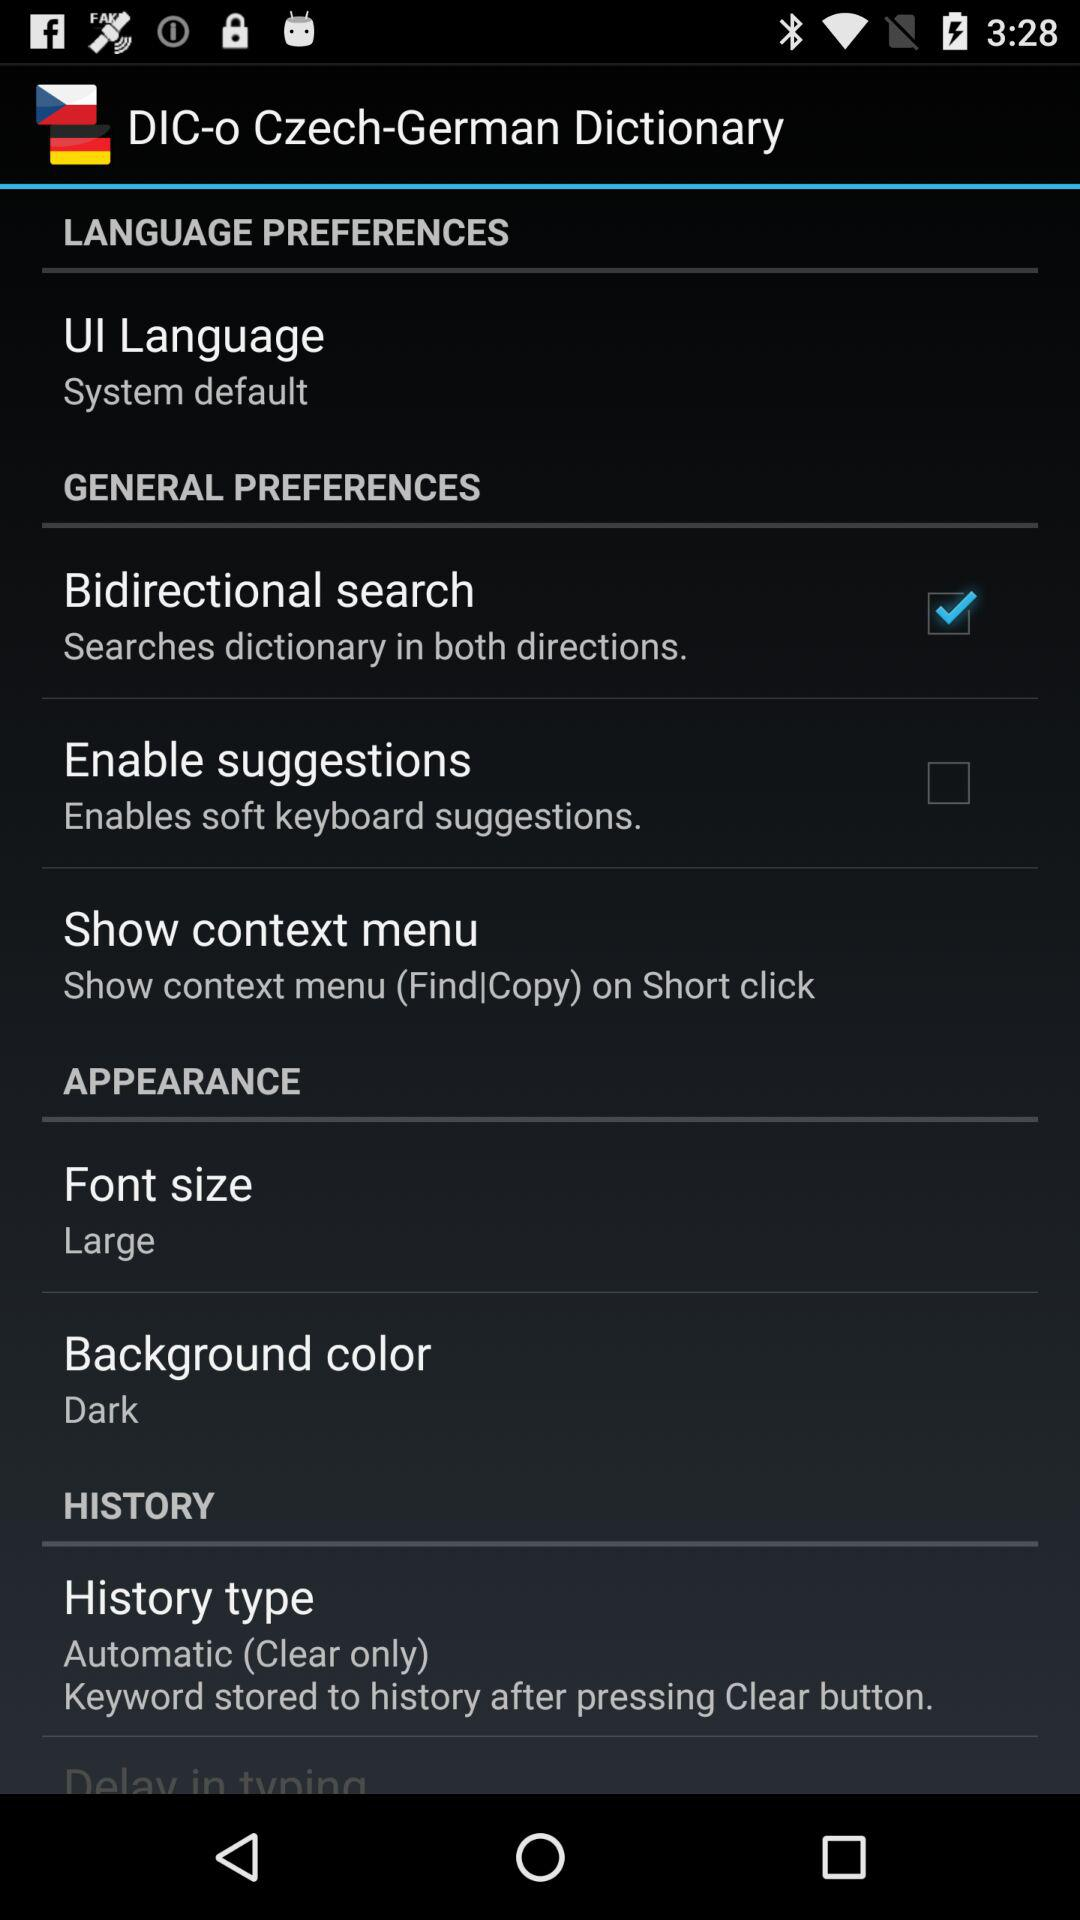How many points is the large font size?
When the provided information is insufficient, respond with <no answer>. <no answer> 